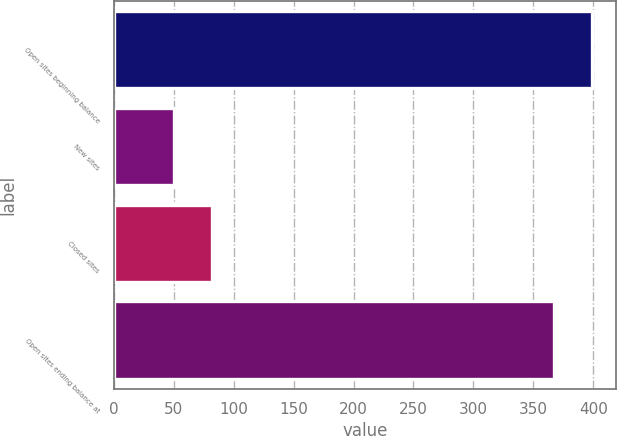<chart> <loc_0><loc_0><loc_500><loc_500><bar_chart><fcel>Open sites beginning balance<fcel>New sites<fcel>Closed sites<fcel>Open sites ending balance at<nl><fcel>399<fcel>50<fcel>82<fcel>367<nl></chart> 